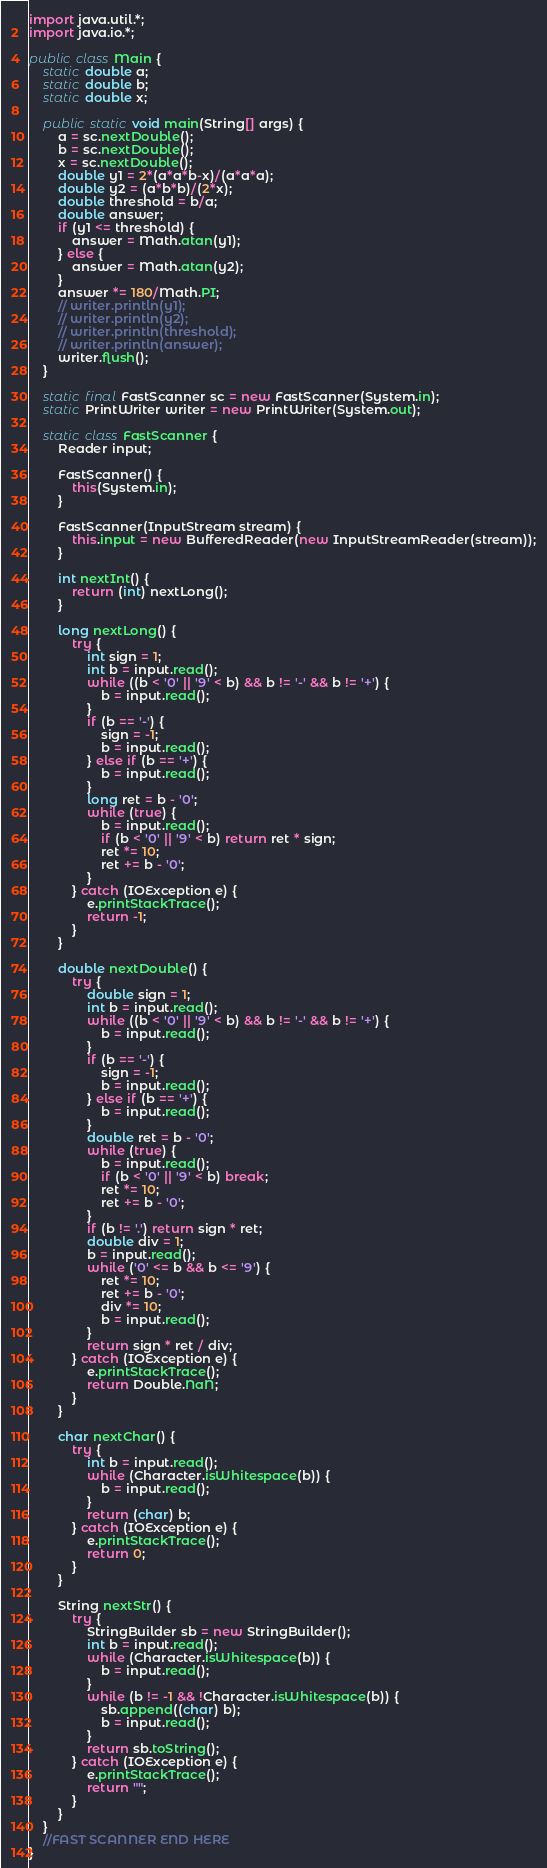Convert code to text. <code><loc_0><loc_0><loc_500><loc_500><_Java_>import java.util.*;
import java.io.*;

public class Main {
    static double a;
    static double b;
    static double x;
    
    public static void main(String[] args) {
        a = sc.nextDouble();
        b = sc.nextDouble();
        x = sc.nextDouble();
        double y1 = 2*(a*a*b-x)/(a*a*a);
        double y2 = (a*b*b)/(2*x);
        double threshold = b/a;
        double answer;
        if (y1 <= threshold) {
            answer = Math.atan(y1);
        } else {
            answer = Math.atan(y2);
        }
        answer *= 180/Math.PI;
        // writer.println(y1);
        // writer.println(y2);
        // writer.println(threshold);
        // writer.println(answer);
        writer.flush();
    }

    static final FastScanner sc = new FastScanner(System.in);
    static PrintWriter writer = new PrintWriter(System.out);

    static class FastScanner {
        Reader input;
 
        FastScanner() {
            this(System.in);
        }
 
        FastScanner(InputStream stream) {
            this.input = new BufferedReader(new InputStreamReader(stream));
        }
 
        int nextInt() {
            return (int) nextLong();
        }
 
        long nextLong() {
            try {
                int sign = 1;
                int b = input.read();
                while ((b < '0' || '9' < b) && b != '-' && b != '+') {
                    b = input.read();
                }
                if (b == '-') {
                    sign = -1;
                    b = input.read();
                } else if (b == '+') {
                    b = input.read();
                }
                long ret = b - '0';
                while (true) {
                    b = input.read();
                    if (b < '0' || '9' < b) return ret * sign;
                    ret *= 10;
                    ret += b - '0';
                }
            } catch (IOException e) {
                e.printStackTrace();
                return -1;
            }
        }
 
        double nextDouble() {
            try {
                double sign = 1;
                int b = input.read();
                while ((b < '0' || '9' < b) && b != '-' && b != '+') {
                    b = input.read();
                }
                if (b == '-') {
                    sign = -1;
                    b = input.read();
                } else if (b == '+') {
                    b = input.read();
                }
                double ret = b - '0';
                while (true) {
                    b = input.read();
                    if (b < '0' || '9' < b) break;
                    ret *= 10;
                    ret += b - '0';
                }
                if (b != '.') return sign * ret;
                double div = 1;
                b = input.read();
                while ('0' <= b && b <= '9') {
                    ret *= 10;
                    ret += b - '0';
                    div *= 10;
                    b = input.read();
                }
                return sign * ret / div;
            } catch (IOException e) {
                e.printStackTrace();
                return Double.NaN;
            }
        }
 
        char nextChar() {
            try {
                int b = input.read();
                while (Character.isWhitespace(b)) {
                    b = input.read();
                }
                return (char) b;
            } catch (IOException e) {
                e.printStackTrace();
                return 0;
            }
        }
 
        String nextStr() {
            try {
                StringBuilder sb = new StringBuilder();
                int b = input.read();
                while (Character.isWhitespace(b)) {
                    b = input.read();
                }
                while (b != -1 && !Character.isWhitespace(b)) {
                    sb.append((char) b);
                    b = input.read();
                }
                return sb.toString();
            } catch (IOException e) {
                e.printStackTrace();
                return "";
            }
        }
    }
    //FAST SCANNER END HERE
}
</code> 